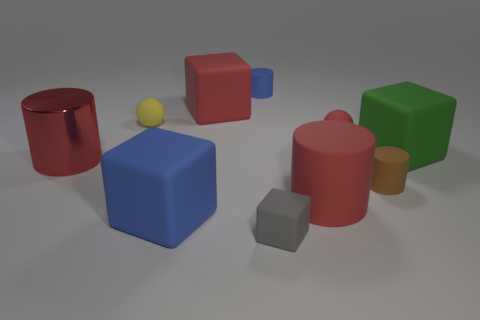Subtract all cylinders. How many objects are left? 6 Subtract 1 brown cylinders. How many objects are left? 9 Subtract all rubber cubes. Subtract all matte blocks. How many objects are left? 2 Add 3 large matte blocks. How many large matte blocks are left? 6 Add 4 yellow rubber balls. How many yellow rubber balls exist? 5 